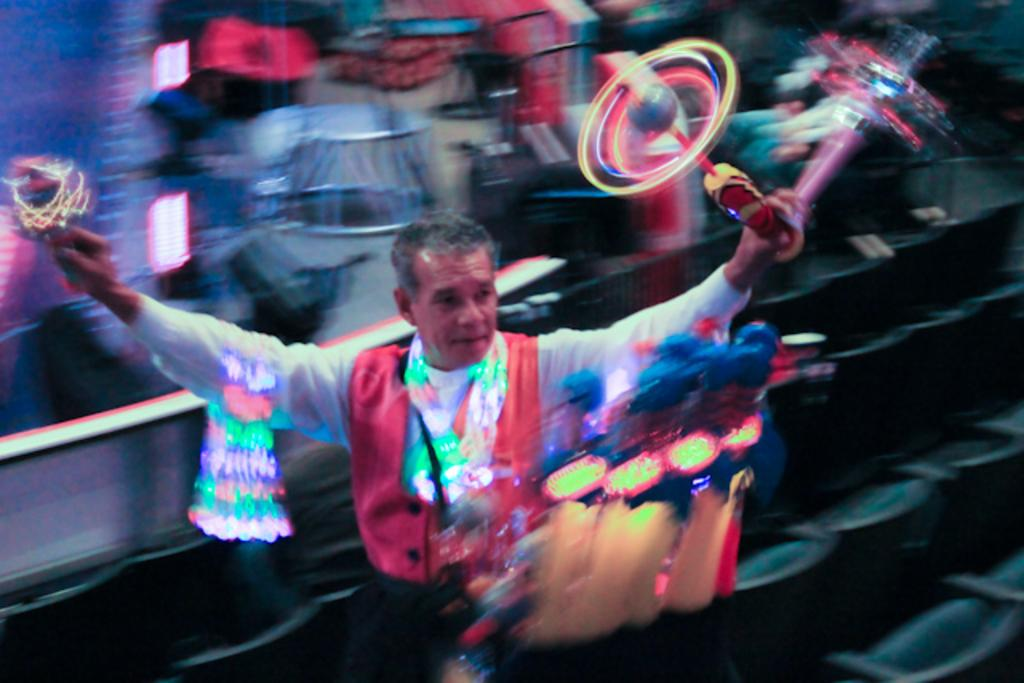What is present in the image? There is a person in the image. What is the person holding? The person is holding something. Can you describe the background of the image? The background of the image is blurred. What type of rock is the carpenter using to make pizzas in the image? There is no rock, carpenter, or pizzas present in the image. 